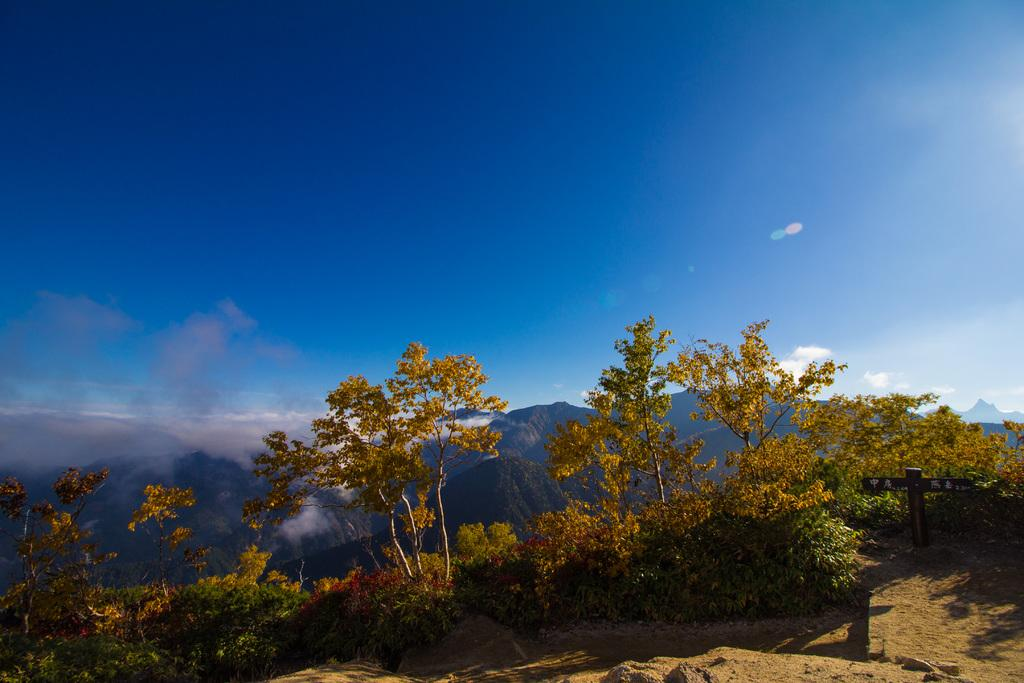What type of vegetation can be seen in the image? There are trees and small bushes in the image. What is attached to a pole in the image? There is a board attached to a pole in the image. What can be seen in the distance in the image? Mountains are visible in the background of the image. What part of the natural environment is visible in the image? The sky is visible in the image. What type of fruit is being bitten by a person in the image? There is no person or fruit being bitten in the image; it features trees, small bushes, a board attached to a pole, mountains in the background, and the sky. How many bags of popcorn are visible in the image? There are no bags of popcorn present in the image. 